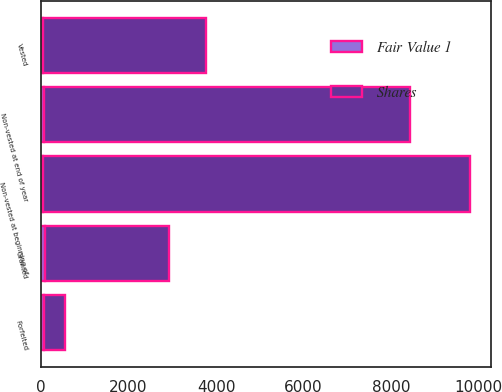<chart> <loc_0><loc_0><loc_500><loc_500><stacked_bar_chart><ecel><fcel>Non-vested at beginning of<fcel>Granted<fcel>Vested<fcel>Forfeited<fcel>Non-vested at end of year<nl><fcel>Shares<fcel>9759<fcel>2844<fcel>3732<fcel>490<fcel>8381<nl><fcel>Fair Value 1<fcel>51<fcel>84<fcel>49<fcel>58<fcel>63<nl></chart> 